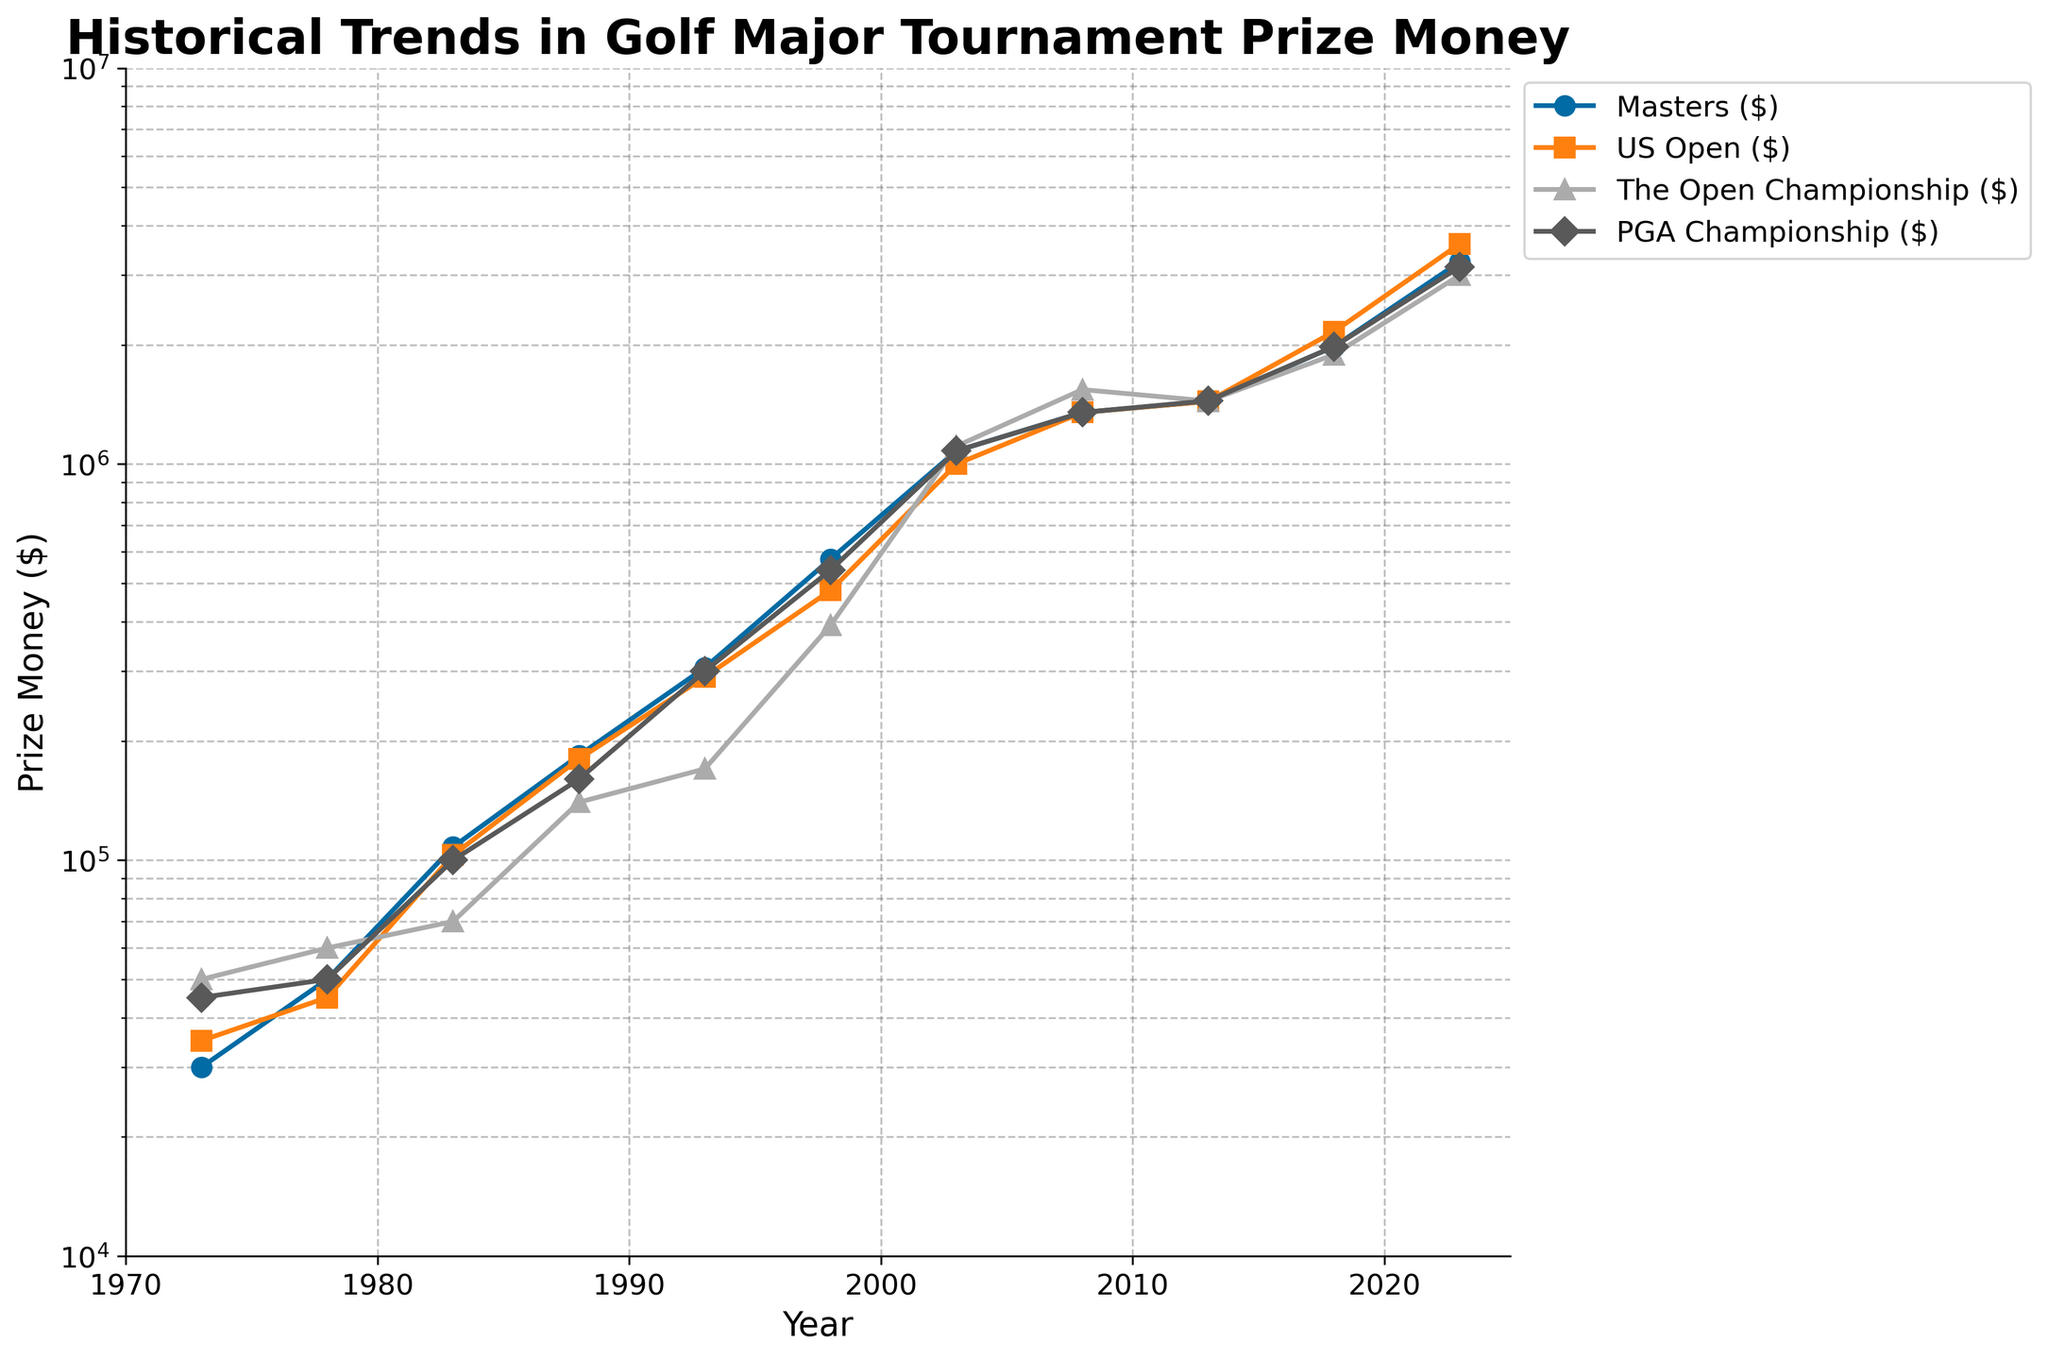What year did the Masters tournament prize money first exceed $1,000,000? Look at the trend line for the Masters ($). It first exceeds $1,000,000 in the year 2003.
Answer: 2003 Which tournament had the highest prize money in 2023? Compare the terminal values in 2023 for the Masters ($), US Open ($), The Open Championship ($), and PGA Championship ($). The US Open ($) had the highest prize amount of $3,600,000.
Answer: US Open Between which two consecutive years did the Masters tournament see the largest increase in prize money? Calculate the differences between consecutive years for the Masters ($). The largest increase is between 1998 ($576,000) and 2003 ($1,080,000), yielding an increase of $504,000.
Answer: 1998 to 2003 How many years did it take for the US Open prize money to double from 2008's value? Starting with the US Open ($)'s 2008 value of $1,350,000, follow the years until the amount surpasses $2,700,000. It surpasses this value in 2023 with $3,600,000. Therefore, it took from 2008 to 2023, which is 15 years.
Answer: 15 years What is the ratio of PGA Championship prize money in 2018 to that in 1978? Divide the prize money of the PGA Championship in 2018 ($1,980,000) by that in 1978 ($50,000). The calculation gives: $1,980,000 / $50,000 = 39.6.
Answer: 39.6 Which tournament showed the smallest increase in prize money from 1993 to 1998? Calculate the increase for each tournament between 1993 and 1998, then compare: Masters ($270,000), US Open ($190,000), The Open Championship ($222,000), PGA Championship ($240,000). The US Open had the smallest increase of $190,000.
Answer: US Open On which year did all tournaments have prize money values exceeding $1,000,000 for the first time? Check each tournament's trend line for the first common year when all prize money values exceed $1,000,000. All tournaments surpassed $1,000,000 the first time in 2003.
Answer: 2003 Which tournament had the sharpest visual increase (steepest line) during the period 2008 to 2013? Compare the slope of the lines for 2008 to 2013. Visually, The Open Championship ($) has the steepest slope indicating the sharpest increase.
Answer: The Open Championship What was the difference in prize money between the Masters (1973) and the US Open (2023)? Subtract the 1973 Masters ($30,000) from the 2023 US Open ($3,600,000): $3,600,000 - $30,000 = $3,570,000.
Answer: $3,570,000 Which tournament exhibited the least volatility in prize money increments over the 50-year span? Visually, compare the smoothness and consistency of the lines. The Masters tournament ($) appears to have the most consistent and least volatile increments.
Answer: Masters 